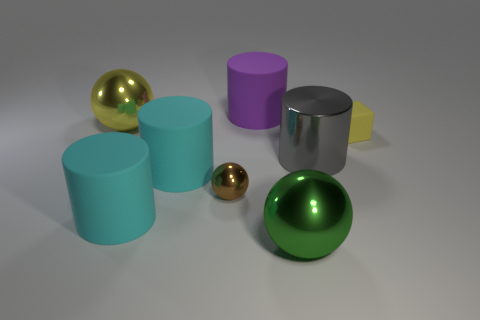Subtract all large matte cylinders. How many cylinders are left? 1 Subtract all yellow balls. How many balls are left? 2 Add 1 brown shiny balls. How many objects exist? 9 Subtract 2 spheres. How many spheres are left? 1 Subtract all cubes. How many objects are left? 7 Subtract all metallic cylinders. Subtract all cyan cylinders. How many objects are left? 5 Add 5 big metal things. How many big metal things are left? 8 Add 1 gray metallic cylinders. How many gray metallic cylinders exist? 2 Subtract 0 red cubes. How many objects are left? 8 Subtract all cyan cylinders. Subtract all yellow blocks. How many cylinders are left? 2 